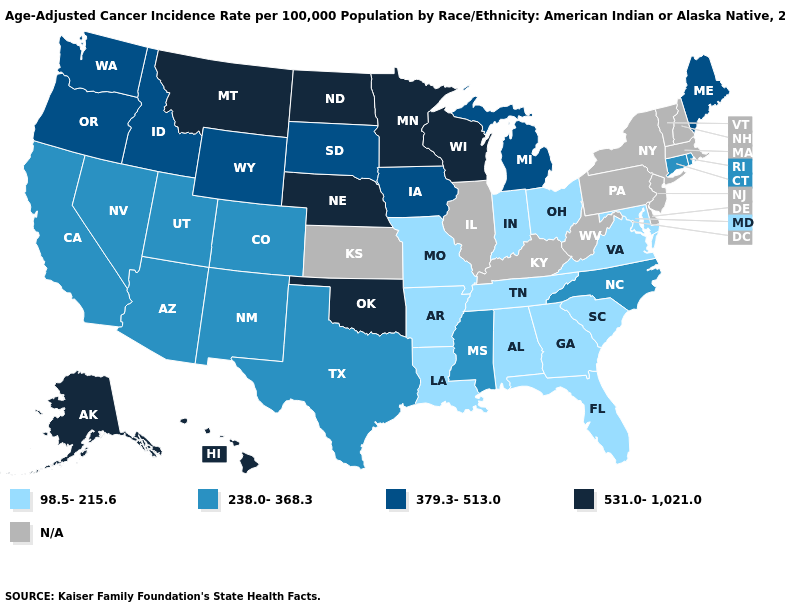Among the states that border Nebraska , which have the lowest value?
Quick response, please. Missouri. Which states have the lowest value in the USA?
Give a very brief answer. Alabama, Arkansas, Florida, Georgia, Indiana, Louisiana, Maryland, Missouri, Ohio, South Carolina, Tennessee, Virginia. What is the lowest value in states that border Missouri?
Quick response, please. 98.5-215.6. What is the value of Louisiana?
Answer briefly. 98.5-215.6. What is the value of South Dakota?
Keep it brief. 379.3-513.0. Name the states that have a value in the range 379.3-513.0?
Short answer required. Idaho, Iowa, Maine, Michigan, Oregon, South Dakota, Washington, Wyoming. Which states hav the highest value in the Northeast?
Write a very short answer. Maine. What is the value of Tennessee?
Keep it brief. 98.5-215.6. What is the value of Maine?
Be succinct. 379.3-513.0. How many symbols are there in the legend?
Write a very short answer. 5. What is the value of North Dakota?
Give a very brief answer. 531.0-1,021.0. What is the value of Idaho?
Quick response, please. 379.3-513.0. Name the states that have a value in the range N/A?
Keep it brief. Delaware, Illinois, Kansas, Kentucky, Massachusetts, New Hampshire, New Jersey, New York, Pennsylvania, Vermont, West Virginia. 